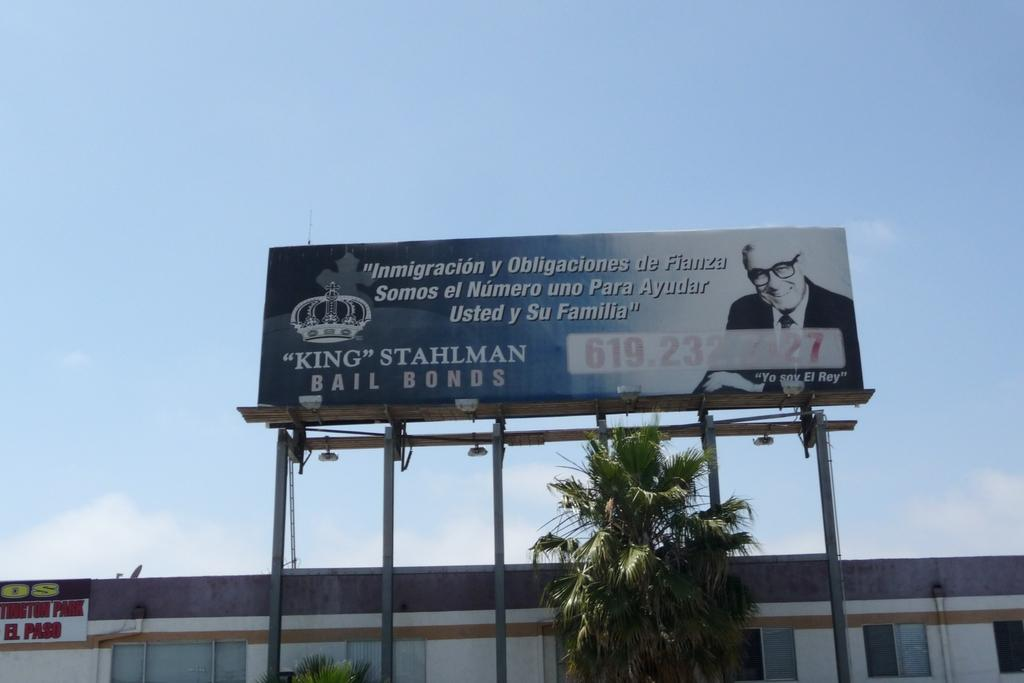<image>
Give a short and clear explanation of the subsequent image. A giant billboard above a palm tree says King Stahlman Bail Bonds. 